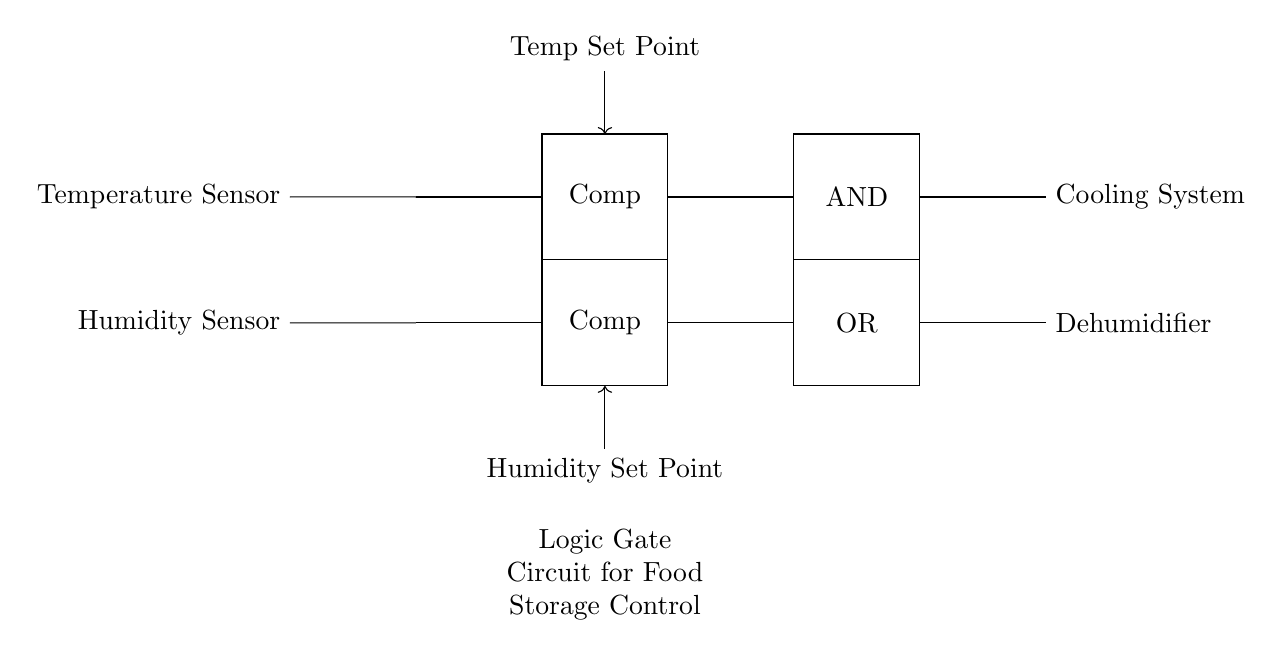What components are included in this circuit? The circuit includes a temperature sensor, a humidity sensor, two comparators, an AND gate, an OR gate, a cooling system, and a dehumidifier. Each component serves a distinct role in regulating the environment for food storage.
Answer: temperature sensor, humidity sensor, comparators, AND gate, OR gate, cooling system, dehumidifier What is the purpose of the AND gate in this circuit? The AND gate processes inputs from the comparators to determine if both temperature and humidity conditions meet the preset criteria for activating the cooling system. It ensures that the cooling system only operates when required based on both inputs.
Answer: To control the cooling system How many sensors are used in the circuit? The circuit consists of two sensors: one for temperature and one for humidity, which monitor the respective conditions inside the food storage unit.
Answer: Two Which component determines the temperature set point? The component labeled 'Temp Set Point' is connected to the comparator, which compares the sensor input with the set point to manage the cooling system.
Answer: Comparator Explain how the OR gate functions in relation to the dehumidifier. The OR gate takes the output from the comparator related to humidity and any other relevant input. If either condition indicates that dehumidification is necessary—either because the humidity is above the set point or the temperature condition requires it—the OR gate activates the dehumidifier. This allows for more flexible control based on multiple inputs.
Answer: Activates the dehumidifier What is the overall function of this logic gate circuit? The circuit's primary function is to continuously monitor and regulate the temperature and humidity levels in food storage units, ensuring optimal storage conditions for food safety and quality through automated control systems.
Answer: Temperature and humidity control 